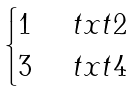<formula> <loc_0><loc_0><loc_500><loc_500>\begin{cases} 1 & \ t x t { 2 } \\ 3 & \ t x t { 4 } \end{cases}</formula> 